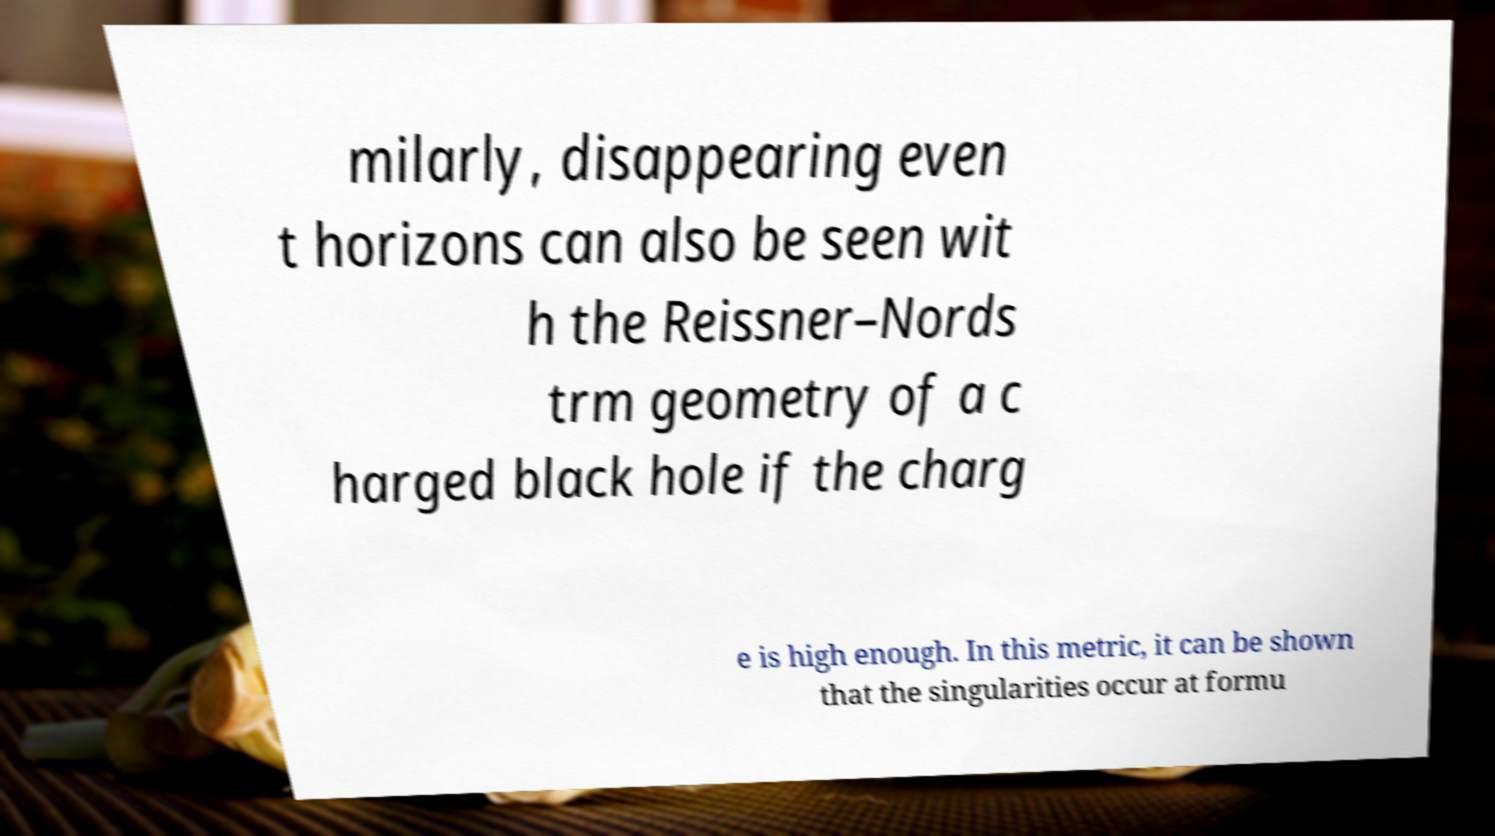Please read and relay the text visible in this image. What does it say? milarly, disappearing even t horizons can also be seen wit h the Reissner–Nords trm geometry of a c harged black hole if the charg e is high enough. In this metric, it can be shown that the singularities occur at formu 